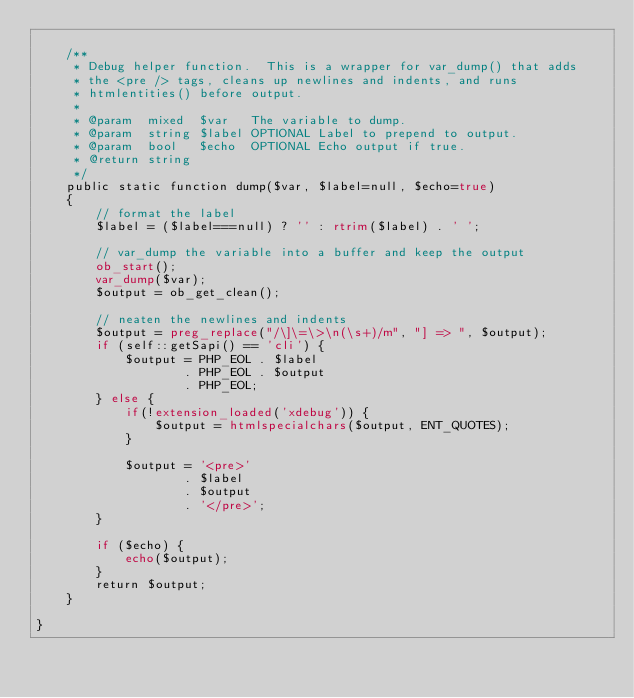Convert code to text. <code><loc_0><loc_0><loc_500><loc_500><_PHP_>
    /**
     * Debug helper function.  This is a wrapper for var_dump() that adds
     * the <pre /> tags, cleans up newlines and indents, and runs
     * htmlentities() before output.
     *
     * @param  mixed  $var   The variable to dump.
     * @param  string $label OPTIONAL Label to prepend to output.
     * @param  bool   $echo  OPTIONAL Echo output if true.
     * @return string
     */
    public static function dump($var, $label=null, $echo=true)
    {
        // format the label
        $label = ($label===null) ? '' : rtrim($label) . ' ';

        // var_dump the variable into a buffer and keep the output
        ob_start();
        var_dump($var);
        $output = ob_get_clean();

        // neaten the newlines and indents
        $output = preg_replace("/\]\=\>\n(\s+)/m", "] => ", $output);
        if (self::getSapi() == 'cli') {
            $output = PHP_EOL . $label
                    . PHP_EOL . $output
                    . PHP_EOL;
        } else {
            if(!extension_loaded('xdebug')) {
                $output = htmlspecialchars($output, ENT_QUOTES);
            }

            $output = '<pre>'
                    . $label
                    . $output
                    . '</pre>';
        }

        if ($echo) {
            echo($output);
        }
        return $output;
    }

}
</code> 